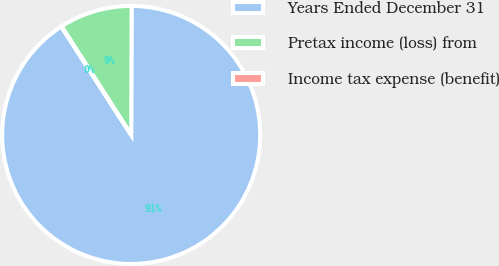Convert chart to OTSL. <chart><loc_0><loc_0><loc_500><loc_500><pie_chart><fcel>Years Ended December 31<fcel>Pretax income (loss) from<fcel>Income tax expense (benefit)<nl><fcel>90.83%<fcel>9.12%<fcel>0.05%<nl></chart> 